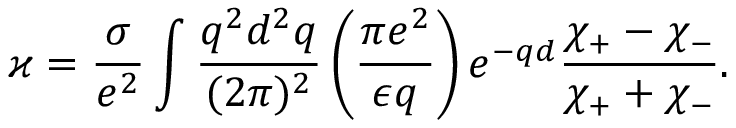<formula> <loc_0><loc_0><loc_500><loc_500>\varkappa = \frac { \sigma } { e ^ { 2 } } \int \frac { q ^ { 2 } d ^ { 2 } q } { ( 2 \pi ) ^ { 2 } } \left ( \frac { \pi e ^ { 2 } } { \epsilon q } \right ) e ^ { - q d } \frac { \chi _ { + } - \chi _ { - } } { \chi _ { + } + \chi _ { - } } .</formula> 